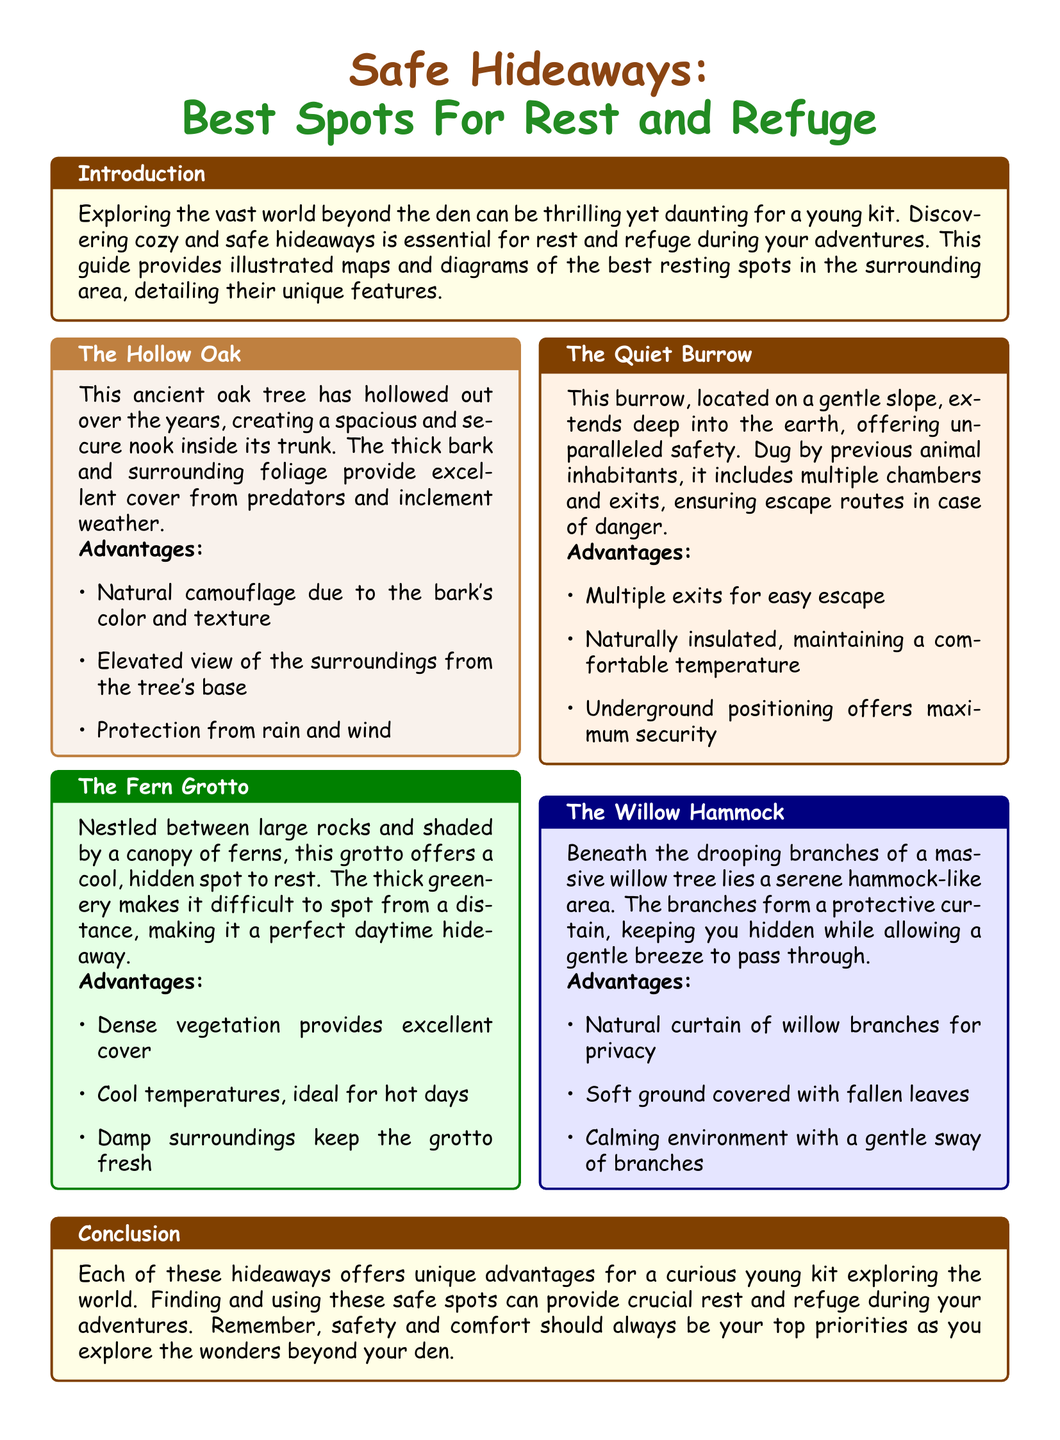What is the title of the document? The title is prominently displayed at the top and describes the main focus of the content.
Answer: Safe Hideaways: Best Spots For Rest and Refuge What is the main advantage of The Hollow Oak? The advantages are listed in bullet points under each hideaway, specifically mentioning natural camouflage.
Answer: Natural camouflage due to the bark's color and texture Which hideaway offers a cool spot to rest? This is noted in the description of The Fern Grotto, emphasizing its temperature advantages.
Answer: The Fern Grotto How many exits does The Quiet Burrow have? The advantages section points out that there are multiple exits for safety.
Answer: Multiple exits What type of tree is The Willow Hammock beneath? The description includes the specific type of tree that provides the shelter.
Answer: Willow tree In which section is the introduction located? The introduction is highlighted in a colored box at the beginning of the document.
Answer: Introduction What is a key feature of The Quiet Burrow? The document specifies an important characteristic of The Quiet Burrow for safety.
Answer: Underground positioning offers maximum security What color is the background of the title box? The color of the title box is explicitly mentioned in the layout's formatting.
Answer: white 